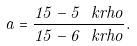<formula> <loc_0><loc_0><loc_500><loc_500>a = \frac { 1 5 - 5 \ k r h o } { 1 5 - 6 \ k r h o } .</formula> 